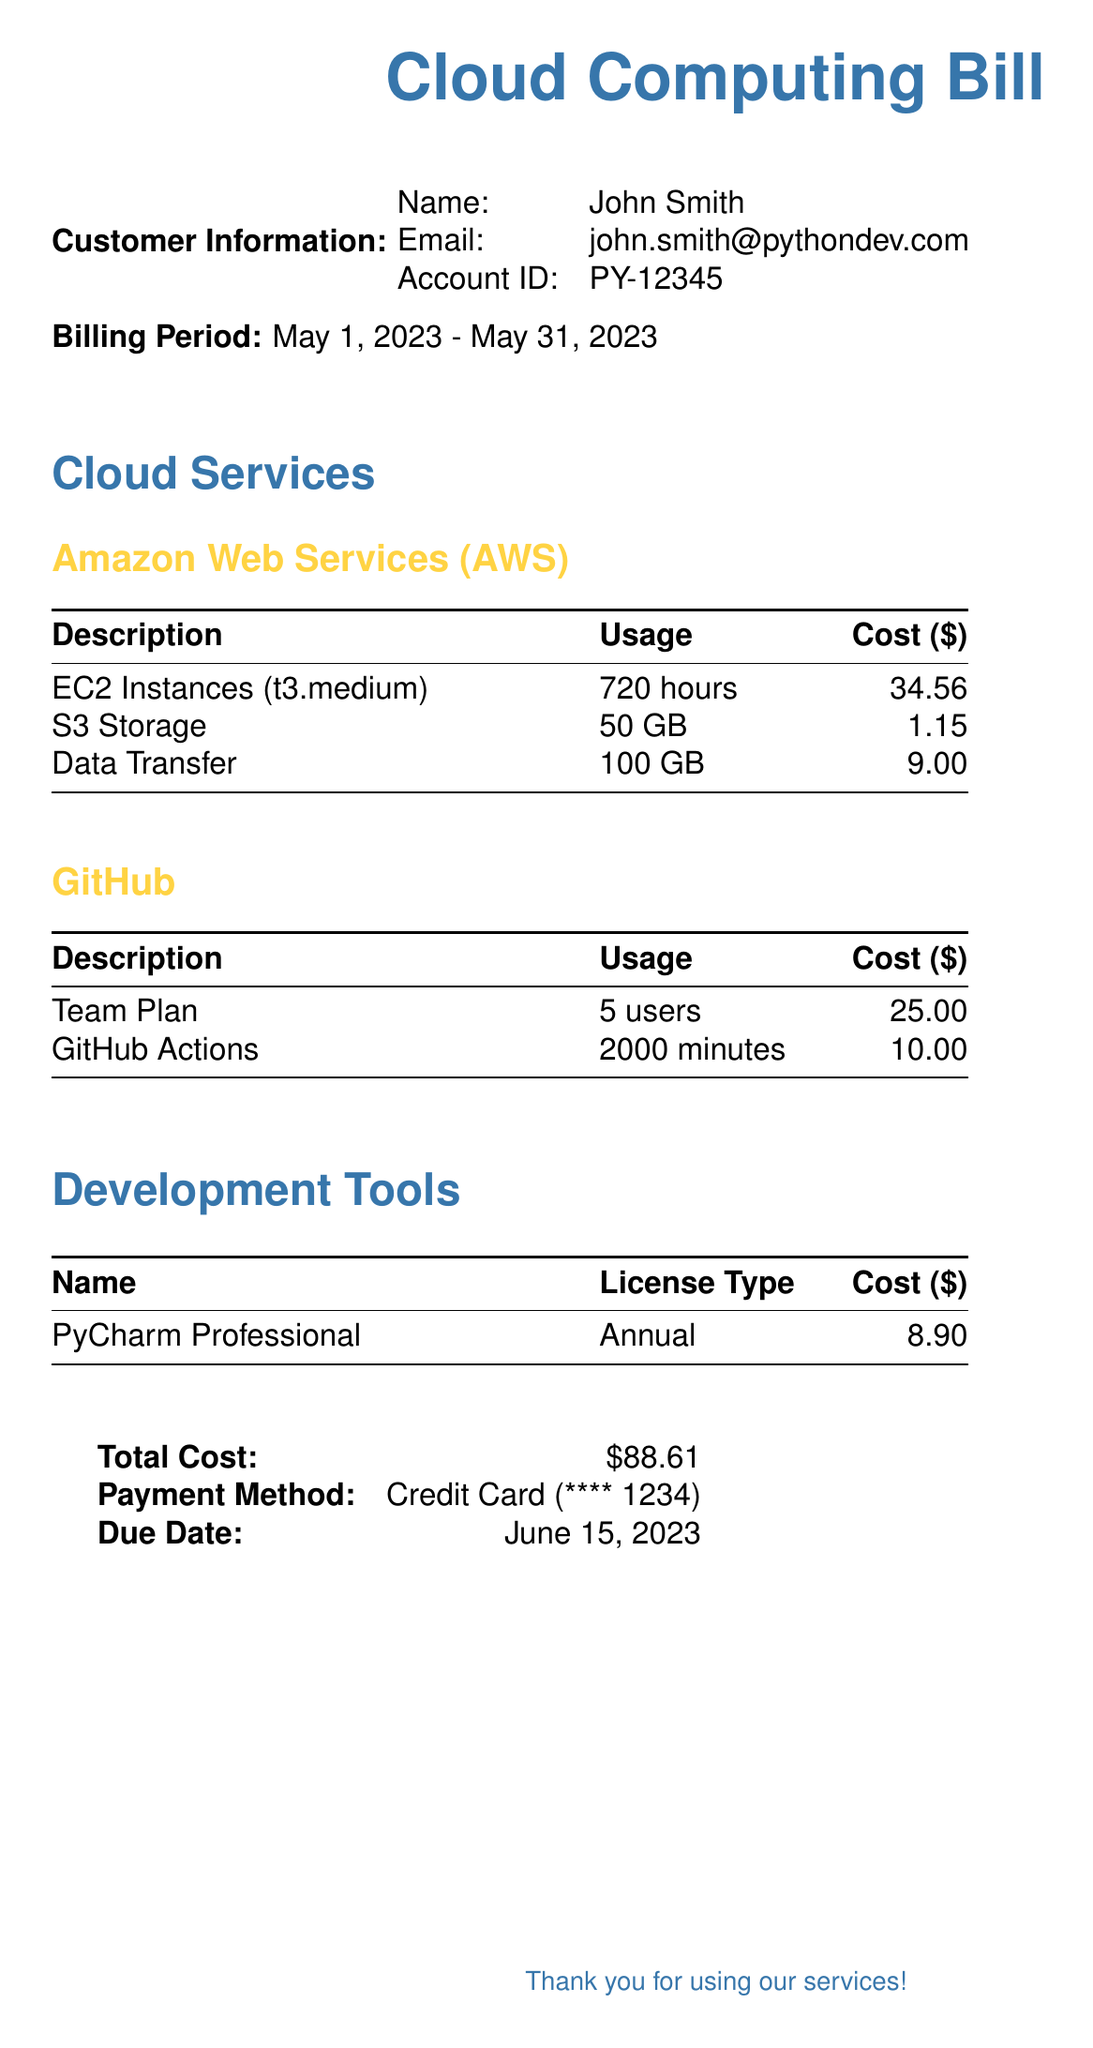What is the customer name? The customer name is listed under Customer Information in the document.
Answer: John Smith What is the billing period? The billing period is highlighted in the document and specifies the duration for which services were billed.
Answer: May 1, 2023 - May 31, 2023 How much did the EC2 Instances cost? The cost of the EC2 Instances is specified in the AWS section of the document.
Answer: 34.56 How many GB of S3 Storage was used? The usage for S3 Storage is provided in the AWS services section.
Answer: 50 GB What is the total cost? The total cost is clearly stated at the end of the document and is the aggregate of all services.
Answer: 88.61 When is the due date for payment? The due date is indicated towards the end of the document.
Answer: June 15, 2023 How many users are included in the GitHub Team Plan? The number of users in the GitHub Team Plan is provided in the GitHub section of the document.
Answer: 5 users What is the cost of the PyCharm Professional license? The cost of the PyCharm Professional license is given under the Development Tools section.
Answer: 8.90 What payment method is used? The payment method is noted at the bottom of the document indicating how the bill will be paid.
Answer: Credit Card (**** 1234) 